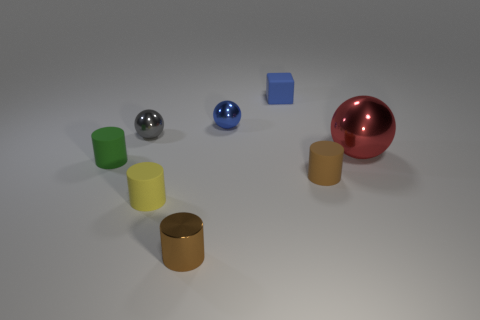Add 1 gray metallic spheres. How many objects exist? 9 Subtract all balls. How many objects are left? 5 Add 8 small green cylinders. How many small green cylinders are left? 9 Add 1 gray spheres. How many gray spheres exist? 2 Subtract all green cylinders. How many cylinders are left? 3 Subtract all small rubber cylinders. How many cylinders are left? 1 Subtract 0 blue cylinders. How many objects are left? 8 Subtract 1 cylinders. How many cylinders are left? 3 Subtract all blue cylinders. Subtract all brown cubes. How many cylinders are left? 4 Subtract all gray cylinders. How many yellow cubes are left? 0 